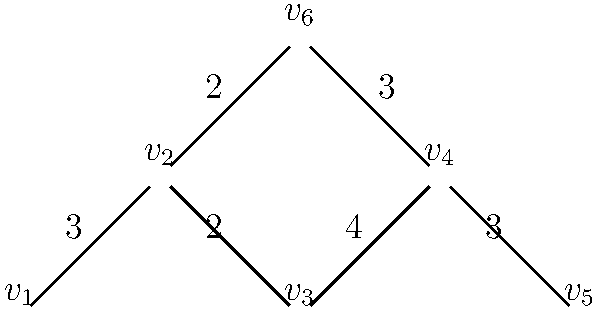In a rural Croatian village, you need to place Wi-Fi hotspots to maximize coverage. The network diagram represents possible locations for hotspots, with vertices as potential sites and edges as connections between sites. Edge weights indicate the number of households covered if hotspots are placed at both connected vertices. What is the maximum number of households that can be covered by placing 3 Wi-Fi hotspots? To solve this problem, we need to find the maximum coverage using 3 Wi-Fi hotspots. Let's approach this step-by-step:

1) First, we need to consider all possible combinations of 3 vertices and calculate the total coverage for each combination.

2) The coverage for a combination is the sum of the weights of all edges that have at least one endpoint in the chosen set of vertices.

3) Let's calculate the coverage for some combinations:

   a) $\{v_1, v_2, v_3\}$: 3 + 2 + 4 = 9
   b) $\{v_1, v_2, v_6\}$: 3 + 2 + 2 = 7
   c) $\{v_2, v_3, v_4\}$: 2 + 4 + 3 = 9
   d) $\{v_2, v_4, v_6\}$: 2 + 4 + 3 + 2 + 3 = 14
   e) $\{v_1, v_3, v_5\}$: 3 + 2 + 4 + 3 = 12

4) After checking all possibilities, we find that the maximum coverage is achieved by placing hotspots at vertices $v_2$, $v_4$, and $v_6$.

5) This combination covers the edges with weights 2, 4, 3, 2, and 3, giving a total coverage of 14 households.

Therefore, the maximum number of households that can be covered by placing 3 Wi-Fi hotspots is 14.
Answer: 14 households 